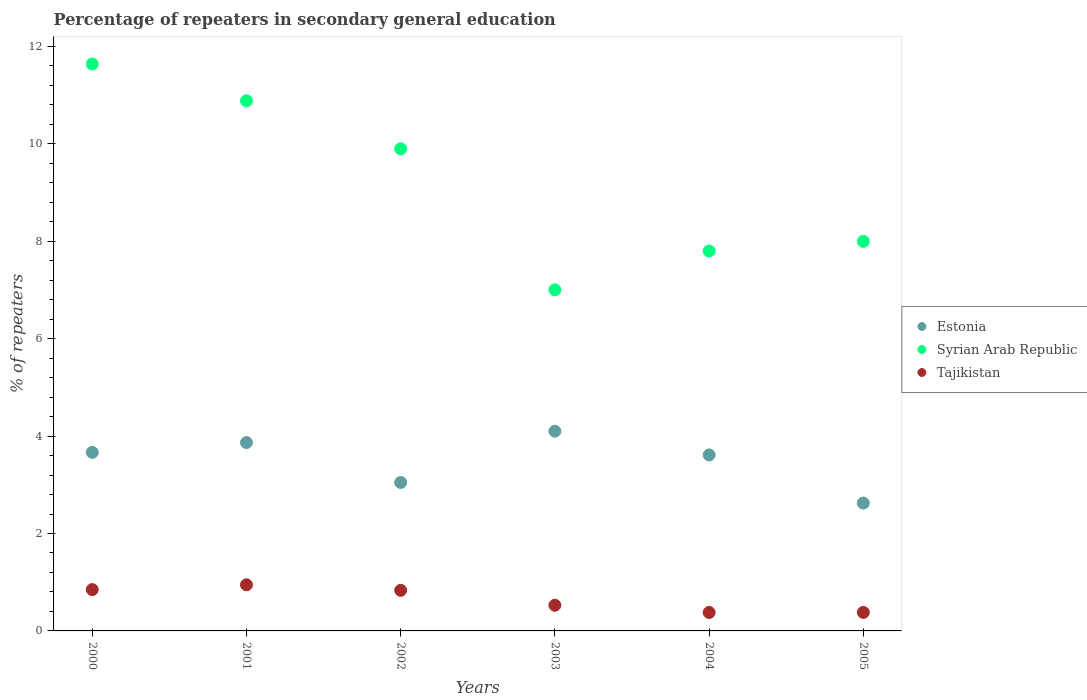What is the percentage of repeaters in secondary general education in Tajikistan in 2000?
Provide a short and direct response. 0.85. Across all years, what is the maximum percentage of repeaters in secondary general education in Syrian Arab Republic?
Provide a short and direct response. 11.64. Across all years, what is the minimum percentage of repeaters in secondary general education in Tajikistan?
Your answer should be very brief. 0.38. In which year was the percentage of repeaters in secondary general education in Tajikistan maximum?
Provide a short and direct response. 2001. In which year was the percentage of repeaters in secondary general education in Syrian Arab Republic minimum?
Offer a very short reply. 2003. What is the total percentage of repeaters in secondary general education in Syrian Arab Republic in the graph?
Make the answer very short. 55.21. What is the difference between the percentage of repeaters in secondary general education in Tajikistan in 2004 and that in 2005?
Offer a very short reply. -0. What is the difference between the percentage of repeaters in secondary general education in Estonia in 2002 and the percentage of repeaters in secondary general education in Tajikistan in 2000?
Provide a succinct answer. 2.2. What is the average percentage of repeaters in secondary general education in Estonia per year?
Your answer should be very brief. 3.49. In the year 2004, what is the difference between the percentage of repeaters in secondary general education in Syrian Arab Republic and percentage of repeaters in secondary general education in Estonia?
Offer a very short reply. 4.19. In how many years, is the percentage of repeaters in secondary general education in Syrian Arab Republic greater than 6 %?
Ensure brevity in your answer.  6. What is the ratio of the percentage of repeaters in secondary general education in Syrian Arab Republic in 2002 to that in 2003?
Offer a very short reply. 1.41. Is the percentage of repeaters in secondary general education in Syrian Arab Republic in 2000 less than that in 2002?
Offer a very short reply. No. Is the difference between the percentage of repeaters in secondary general education in Syrian Arab Republic in 2003 and 2004 greater than the difference between the percentage of repeaters in secondary general education in Estonia in 2003 and 2004?
Offer a terse response. No. What is the difference between the highest and the second highest percentage of repeaters in secondary general education in Tajikistan?
Your answer should be very brief. 0.1. What is the difference between the highest and the lowest percentage of repeaters in secondary general education in Tajikistan?
Your answer should be compact. 0.57. In how many years, is the percentage of repeaters in secondary general education in Syrian Arab Republic greater than the average percentage of repeaters in secondary general education in Syrian Arab Republic taken over all years?
Provide a short and direct response. 3. Does the percentage of repeaters in secondary general education in Tajikistan monotonically increase over the years?
Offer a very short reply. No. Is the percentage of repeaters in secondary general education in Syrian Arab Republic strictly greater than the percentage of repeaters in secondary general education in Tajikistan over the years?
Give a very brief answer. Yes. Is the percentage of repeaters in secondary general education in Syrian Arab Republic strictly less than the percentage of repeaters in secondary general education in Estonia over the years?
Your answer should be compact. No. How many years are there in the graph?
Your answer should be very brief. 6. What is the difference between two consecutive major ticks on the Y-axis?
Your answer should be compact. 2. Are the values on the major ticks of Y-axis written in scientific E-notation?
Your answer should be very brief. No. Does the graph contain grids?
Make the answer very short. No. Where does the legend appear in the graph?
Keep it short and to the point. Center right. How are the legend labels stacked?
Offer a very short reply. Vertical. What is the title of the graph?
Provide a short and direct response. Percentage of repeaters in secondary general education. Does "Tanzania" appear as one of the legend labels in the graph?
Make the answer very short. No. What is the label or title of the Y-axis?
Provide a short and direct response. % of repeaters. What is the % of repeaters of Estonia in 2000?
Provide a short and direct response. 3.67. What is the % of repeaters in Syrian Arab Republic in 2000?
Offer a very short reply. 11.64. What is the % of repeaters in Tajikistan in 2000?
Your response must be concise. 0.85. What is the % of repeaters in Estonia in 2001?
Offer a terse response. 3.87. What is the % of repeaters of Syrian Arab Republic in 2001?
Your response must be concise. 10.88. What is the % of repeaters in Tajikistan in 2001?
Your answer should be compact. 0.95. What is the % of repeaters of Estonia in 2002?
Your answer should be compact. 3.05. What is the % of repeaters in Syrian Arab Republic in 2002?
Give a very brief answer. 9.9. What is the % of repeaters in Tajikistan in 2002?
Your answer should be very brief. 0.83. What is the % of repeaters in Estonia in 2003?
Provide a succinct answer. 4.1. What is the % of repeaters of Syrian Arab Republic in 2003?
Keep it short and to the point. 7. What is the % of repeaters in Tajikistan in 2003?
Make the answer very short. 0.53. What is the % of repeaters in Estonia in 2004?
Provide a succinct answer. 3.61. What is the % of repeaters of Syrian Arab Republic in 2004?
Provide a short and direct response. 7.8. What is the % of repeaters of Tajikistan in 2004?
Ensure brevity in your answer.  0.38. What is the % of repeaters of Estonia in 2005?
Your answer should be very brief. 2.62. What is the % of repeaters of Syrian Arab Republic in 2005?
Your answer should be very brief. 8. What is the % of repeaters in Tajikistan in 2005?
Offer a terse response. 0.38. Across all years, what is the maximum % of repeaters of Estonia?
Ensure brevity in your answer.  4.1. Across all years, what is the maximum % of repeaters of Syrian Arab Republic?
Provide a succinct answer. 11.64. Across all years, what is the maximum % of repeaters in Tajikistan?
Provide a succinct answer. 0.95. Across all years, what is the minimum % of repeaters of Estonia?
Ensure brevity in your answer.  2.62. Across all years, what is the minimum % of repeaters in Syrian Arab Republic?
Your response must be concise. 7. Across all years, what is the minimum % of repeaters in Tajikistan?
Your answer should be compact. 0.38. What is the total % of repeaters of Estonia in the graph?
Your answer should be compact. 20.92. What is the total % of repeaters of Syrian Arab Republic in the graph?
Keep it short and to the point. 55.21. What is the total % of repeaters in Tajikistan in the graph?
Keep it short and to the point. 3.91. What is the difference between the % of repeaters of Estonia in 2000 and that in 2001?
Your response must be concise. -0.2. What is the difference between the % of repeaters in Syrian Arab Republic in 2000 and that in 2001?
Give a very brief answer. 0.76. What is the difference between the % of repeaters in Tajikistan in 2000 and that in 2001?
Make the answer very short. -0.1. What is the difference between the % of repeaters in Estonia in 2000 and that in 2002?
Ensure brevity in your answer.  0.62. What is the difference between the % of repeaters in Syrian Arab Republic in 2000 and that in 2002?
Your answer should be very brief. 1.74. What is the difference between the % of repeaters in Tajikistan in 2000 and that in 2002?
Your answer should be very brief. 0.01. What is the difference between the % of repeaters in Estonia in 2000 and that in 2003?
Ensure brevity in your answer.  -0.43. What is the difference between the % of repeaters of Syrian Arab Republic in 2000 and that in 2003?
Your answer should be very brief. 4.64. What is the difference between the % of repeaters of Tajikistan in 2000 and that in 2003?
Give a very brief answer. 0.32. What is the difference between the % of repeaters of Estonia in 2000 and that in 2004?
Give a very brief answer. 0.05. What is the difference between the % of repeaters of Syrian Arab Republic in 2000 and that in 2004?
Provide a succinct answer. 3.84. What is the difference between the % of repeaters of Tajikistan in 2000 and that in 2004?
Your response must be concise. 0.47. What is the difference between the % of repeaters of Estonia in 2000 and that in 2005?
Make the answer very short. 1.04. What is the difference between the % of repeaters of Syrian Arab Republic in 2000 and that in 2005?
Give a very brief answer. 3.64. What is the difference between the % of repeaters of Tajikistan in 2000 and that in 2005?
Make the answer very short. 0.47. What is the difference between the % of repeaters in Estonia in 2001 and that in 2002?
Your answer should be very brief. 0.82. What is the difference between the % of repeaters of Syrian Arab Republic in 2001 and that in 2002?
Keep it short and to the point. 0.99. What is the difference between the % of repeaters of Tajikistan in 2001 and that in 2002?
Offer a terse response. 0.11. What is the difference between the % of repeaters of Estonia in 2001 and that in 2003?
Provide a succinct answer. -0.23. What is the difference between the % of repeaters in Syrian Arab Republic in 2001 and that in 2003?
Provide a succinct answer. 3.88. What is the difference between the % of repeaters of Tajikistan in 2001 and that in 2003?
Ensure brevity in your answer.  0.42. What is the difference between the % of repeaters of Estonia in 2001 and that in 2004?
Your response must be concise. 0.25. What is the difference between the % of repeaters in Syrian Arab Republic in 2001 and that in 2004?
Keep it short and to the point. 3.08. What is the difference between the % of repeaters of Tajikistan in 2001 and that in 2004?
Ensure brevity in your answer.  0.57. What is the difference between the % of repeaters in Estonia in 2001 and that in 2005?
Provide a short and direct response. 1.24. What is the difference between the % of repeaters in Syrian Arab Republic in 2001 and that in 2005?
Your answer should be compact. 2.89. What is the difference between the % of repeaters in Tajikistan in 2001 and that in 2005?
Provide a succinct answer. 0.57. What is the difference between the % of repeaters in Estonia in 2002 and that in 2003?
Provide a succinct answer. -1.05. What is the difference between the % of repeaters of Syrian Arab Republic in 2002 and that in 2003?
Provide a succinct answer. 2.9. What is the difference between the % of repeaters of Tajikistan in 2002 and that in 2003?
Make the answer very short. 0.31. What is the difference between the % of repeaters of Estonia in 2002 and that in 2004?
Provide a succinct answer. -0.57. What is the difference between the % of repeaters in Syrian Arab Republic in 2002 and that in 2004?
Your answer should be compact. 2.1. What is the difference between the % of repeaters in Tajikistan in 2002 and that in 2004?
Your answer should be very brief. 0.45. What is the difference between the % of repeaters in Estonia in 2002 and that in 2005?
Offer a very short reply. 0.42. What is the difference between the % of repeaters in Syrian Arab Republic in 2002 and that in 2005?
Provide a short and direct response. 1.9. What is the difference between the % of repeaters of Tajikistan in 2002 and that in 2005?
Offer a very short reply. 0.45. What is the difference between the % of repeaters of Estonia in 2003 and that in 2004?
Keep it short and to the point. 0.49. What is the difference between the % of repeaters in Syrian Arab Republic in 2003 and that in 2004?
Your response must be concise. -0.8. What is the difference between the % of repeaters in Tajikistan in 2003 and that in 2004?
Ensure brevity in your answer.  0.15. What is the difference between the % of repeaters of Estonia in 2003 and that in 2005?
Your answer should be compact. 1.48. What is the difference between the % of repeaters in Syrian Arab Republic in 2003 and that in 2005?
Make the answer very short. -1. What is the difference between the % of repeaters in Tajikistan in 2003 and that in 2005?
Give a very brief answer. 0.15. What is the difference between the % of repeaters in Estonia in 2004 and that in 2005?
Your answer should be compact. 0.99. What is the difference between the % of repeaters in Syrian Arab Republic in 2004 and that in 2005?
Your response must be concise. -0.2. What is the difference between the % of repeaters in Tajikistan in 2004 and that in 2005?
Offer a very short reply. -0. What is the difference between the % of repeaters in Estonia in 2000 and the % of repeaters in Syrian Arab Republic in 2001?
Your answer should be compact. -7.22. What is the difference between the % of repeaters of Estonia in 2000 and the % of repeaters of Tajikistan in 2001?
Give a very brief answer. 2.72. What is the difference between the % of repeaters in Syrian Arab Republic in 2000 and the % of repeaters in Tajikistan in 2001?
Ensure brevity in your answer.  10.69. What is the difference between the % of repeaters in Estonia in 2000 and the % of repeaters in Syrian Arab Republic in 2002?
Your answer should be compact. -6.23. What is the difference between the % of repeaters of Estonia in 2000 and the % of repeaters of Tajikistan in 2002?
Keep it short and to the point. 2.83. What is the difference between the % of repeaters of Syrian Arab Republic in 2000 and the % of repeaters of Tajikistan in 2002?
Provide a short and direct response. 10.8. What is the difference between the % of repeaters in Estonia in 2000 and the % of repeaters in Syrian Arab Republic in 2003?
Ensure brevity in your answer.  -3.34. What is the difference between the % of repeaters in Estonia in 2000 and the % of repeaters in Tajikistan in 2003?
Provide a succinct answer. 3.14. What is the difference between the % of repeaters of Syrian Arab Republic in 2000 and the % of repeaters of Tajikistan in 2003?
Your answer should be very brief. 11.11. What is the difference between the % of repeaters in Estonia in 2000 and the % of repeaters in Syrian Arab Republic in 2004?
Your answer should be compact. -4.13. What is the difference between the % of repeaters in Estonia in 2000 and the % of repeaters in Tajikistan in 2004?
Give a very brief answer. 3.29. What is the difference between the % of repeaters of Syrian Arab Republic in 2000 and the % of repeaters of Tajikistan in 2004?
Your answer should be very brief. 11.26. What is the difference between the % of repeaters in Estonia in 2000 and the % of repeaters in Syrian Arab Republic in 2005?
Keep it short and to the point. -4.33. What is the difference between the % of repeaters of Estonia in 2000 and the % of repeaters of Tajikistan in 2005?
Your response must be concise. 3.28. What is the difference between the % of repeaters of Syrian Arab Republic in 2000 and the % of repeaters of Tajikistan in 2005?
Give a very brief answer. 11.26. What is the difference between the % of repeaters of Estonia in 2001 and the % of repeaters of Syrian Arab Republic in 2002?
Your answer should be very brief. -6.03. What is the difference between the % of repeaters of Estonia in 2001 and the % of repeaters of Tajikistan in 2002?
Your answer should be compact. 3.03. What is the difference between the % of repeaters in Syrian Arab Republic in 2001 and the % of repeaters in Tajikistan in 2002?
Your answer should be compact. 10.05. What is the difference between the % of repeaters of Estonia in 2001 and the % of repeaters of Syrian Arab Republic in 2003?
Provide a succinct answer. -3.14. What is the difference between the % of repeaters in Estonia in 2001 and the % of repeaters in Tajikistan in 2003?
Make the answer very short. 3.34. What is the difference between the % of repeaters in Syrian Arab Republic in 2001 and the % of repeaters in Tajikistan in 2003?
Your answer should be very brief. 10.36. What is the difference between the % of repeaters of Estonia in 2001 and the % of repeaters of Syrian Arab Republic in 2004?
Give a very brief answer. -3.93. What is the difference between the % of repeaters of Estonia in 2001 and the % of repeaters of Tajikistan in 2004?
Provide a short and direct response. 3.49. What is the difference between the % of repeaters in Syrian Arab Republic in 2001 and the % of repeaters in Tajikistan in 2004?
Provide a succinct answer. 10.5. What is the difference between the % of repeaters of Estonia in 2001 and the % of repeaters of Syrian Arab Republic in 2005?
Keep it short and to the point. -4.13. What is the difference between the % of repeaters of Estonia in 2001 and the % of repeaters of Tajikistan in 2005?
Ensure brevity in your answer.  3.49. What is the difference between the % of repeaters in Syrian Arab Republic in 2001 and the % of repeaters in Tajikistan in 2005?
Your answer should be compact. 10.5. What is the difference between the % of repeaters in Estonia in 2002 and the % of repeaters in Syrian Arab Republic in 2003?
Offer a terse response. -3.95. What is the difference between the % of repeaters in Estonia in 2002 and the % of repeaters in Tajikistan in 2003?
Make the answer very short. 2.52. What is the difference between the % of repeaters of Syrian Arab Republic in 2002 and the % of repeaters of Tajikistan in 2003?
Make the answer very short. 9.37. What is the difference between the % of repeaters of Estonia in 2002 and the % of repeaters of Syrian Arab Republic in 2004?
Your answer should be compact. -4.75. What is the difference between the % of repeaters in Estonia in 2002 and the % of repeaters in Tajikistan in 2004?
Give a very brief answer. 2.67. What is the difference between the % of repeaters of Syrian Arab Republic in 2002 and the % of repeaters of Tajikistan in 2004?
Provide a succinct answer. 9.52. What is the difference between the % of repeaters of Estonia in 2002 and the % of repeaters of Syrian Arab Republic in 2005?
Provide a succinct answer. -4.95. What is the difference between the % of repeaters in Estonia in 2002 and the % of repeaters in Tajikistan in 2005?
Offer a terse response. 2.67. What is the difference between the % of repeaters of Syrian Arab Republic in 2002 and the % of repeaters of Tajikistan in 2005?
Offer a very short reply. 9.52. What is the difference between the % of repeaters in Estonia in 2003 and the % of repeaters in Syrian Arab Republic in 2004?
Keep it short and to the point. -3.7. What is the difference between the % of repeaters in Estonia in 2003 and the % of repeaters in Tajikistan in 2004?
Your answer should be very brief. 3.72. What is the difference between the % of repeaters of Syrian Arab Republic in 2003 and the % of repeaters of Tajikistan in 2004?
Give a very brief answer. 6.62. What is the difference between the % of repeaters in Estonia in 2003 and the % of repeaters in Syrian Arab Republic in 2005?
Give a very brief answer. -3.9. What is the difference between the % of repeaters in Estonia in 2003 and the % of repeaters in Tajikistan in 2005?
Your answer should be compact. 3.72. What is the difference between the % of repeaters in Syrian Arab Republic in 2003 and the % of repeaters in Tajikistan in 2005?
Provide a short and direct response. 6.62. What is the difference between the % of repeaters of Estonia in 2004 and the % of repeaters of Syrian Arab Republic in 2005?
Offer a very short reply. -4.38. What is the difference between the % of repeaters of Estonia in 2004 and the % of repeaters of Tajikistan in 2005?
Your answer should be very brief. 3.23. What is the difference between the % of repeaters of Syrian Arab Republic in 2004 and the % of repeaters of Tajikistan in 2005?
Your answer should be very brief. 7.42. What is the average % of repeaters in Estonia per year?
Provide a succinct answer. 3.49. What is the average % of repeaters in Syrian Arab Republic per year?
Offer a terse response. 9.2. What is the average % of repeaters in Tajikistan per year?
Keep it short and to the point. 0.65. In the year 2000, what is the difference between the % of repeaters of Estonia and % of repeaters of Syrian Arab Republic?
Your answer should be compact. -7.97. In the year 2000, what is the difference between the % of repeaters in Estonia and % of repeaters in Tajikistan?
Offer a very short reply. 2.82. In the year 2000, what is the difference between the % of repeaters of Syrian Arab Republic and % of repeaters of Tajikistan?
Offer a very short reply. 10.79. In the year 2001, what is the difference between the % of repeaters of Estonia and % of repeaters of Syrian Arab Republic?
Your response must be concise. -7.02. In the year 2001, what is the difference between the % of repeaters in Estonia and % of repeaters in Tajikistan?
Your answer should be compact. 2.92. In the year 2001, what is the difference between the % of repeaters in Syrian Arab Republic and % of repeaters in Tajikistan?
Your answer should be compact. 9.94. In the year 2002, what is the difference between the % of repeaters of Estonia and % of repeaters of Syrian Arab Republic?
Your answer should be compact. -6.85. In the year 2002, what is the difference between the % of repeaters in Estonia and % of repeaters in Tajikistan?
Provide a succinct answer. 2.21. In the year 2002, what is the difference between the % of repeaters in Syrian Arab Republic and % of repeaters in Tajikistan?
Offer a terse response. 9.06. In the year 2003, what is the difference between the % of repeaters in Estonia and % of repeaters in Syrian Arab Republic?
Ensure brevity in your answer.  -2.9. In the year 2003, what is the difference between the % of repeaters of Estonia and % of repeaters of Tajikistan?
Give a very brief answer. 3.57. In the year 2003, what is the difference between the % of repeaters of Syrian Arab Republic and % of repeaters of Tajikistan?
Give a very brief answer. 6.47. In the year 2004, what is the difference between the % of repeaters in Estonia and % of repeaters in Syrian Arab Republic?
Your response must be concise. -4.19. In the year 2004, what is the difference between the % of repeaters in Estonia and % of repeaters in Tajikistan?
Your answer should be very brief. 3.23. In the year 2004, what is the difference between the % of repeaters of Syrian Arab Republic and % of repeaters of Tajikistan?
Ensure brevity in your answer.  7.42. In the year 2005, what is the difference between the % of repeaters in Estonia and % of repeaters in Syrian Arab Republic?
Offer a terse response. -5.37. In the year 2005, what is the difference between the % of repeaters in Estonia and % of repeaters in Tajikistan?
Your answer should be very brief. 2.24. In the year 2005, what is the difference between the % of repeaters in Syrian Arab Republic and % of repeaters in Tajikistan?
Give a very brief answer. 7.62. What is the ratio of the % of repeaters in Estonia in 2000 to that in 2001?
Make the answer very short. 0.95. What is the ratio of the % of repeaters of Syrian Arab Republic in 2000 to that in 2001?
Your answer should be very brief. 1.07. What is the ratio of the % of repeaters of Tajikistan in 2000 to that in 2001?
Your response must be concise. 0.9. What is the ratio of the % of repeaters of Estonia in 2000 to that in 2002?
Offer a very short reply. 1.2. What is the ratio of the % of repeaters of Syrian Arab Republic in 2000 to that in 2002?
Keep it short and to the point. 1.18. What is the ratio of the % of repeaters in Tajikistan in 2000 to that in 2002?
Offer a terse response. 1.02. What is the ratio of the % of repeaters of Estonia in 2000 to that in 2003?
Offer a very short reply. 0.89. What is the ratio of the % of repeaters in Syrian Arab Republic in 2000 to that in 2003?
Keep it short and to the point. 1.66. What is the ratio of the % of repeaters of Tajikistan in 2000 to that in 2003?
Your response must be concise. 1.61. What is the ratio of the % of repeaters in Estonia in 2000 to that in 2004?
Give a very brief answer. 1.01. What is the ratio of the % of repeaters in Syrian Arab Republic in 2000 to that in 2004?
Offer a terse response. 1.49. What is the ratio of the % of repeaters of Tajikistan in 2000 to that in 2004?
Make the answer very short. 2.24. What is the ratio of the % of repeaters of Estonia in 2000 to that in 2005?
Your answer should be compact. 1.4. What is the ratio of the % of repeaters in Syrian Arab Republic in 2000 to that in 2005?
Provide a succinct answer. 1.46. What is the ratio of the % of repeaters in Tajikistan in 2000 to that in 2005?
Keep it short and to the point. 2.23. What is the ratio of the % of repeaters of Estonia in 2001 to that in 2002?
Your response must be concise. 1.27. What is the ratio of the % of repeaters of Syrian Arab Republic in 2001 to that in 2002?
Keep it short and to the point. 1.1. What is the ratio of the % of repeaters of Tajikistan in 2001 to that in 2002?
Offer a terse response. 1.14. What is the ratio of the % of repeaters in Estonia in 2001 to that in 2003?
Your answer should be compact. 0.94. What is the ratio of the % of repeaters in Syrian Arab Republic in 2001 to that in 2003?
Provide a succinct answer. 1.55. What is the ratio of the % of repeaters in Tajikistan in 2001 to that in 2003?
Provide a short and direct response. 1.8. What is the ratio of the % of repeaters in Estonia in 2001 to that in 2004?
Ensure brevity in your answer.  1.07. What is the ratio of the % of repeaters of Syrian Arab Republic in 2001 to that in 2004?
Provide a short and direct response. 1.4. What is the ratio of the % of repeaters in Tajikistan in 2001 to that in 2004?
Make the answer very short. 2.5. What is the ratio of the % of repeaters of Estonia in 2001 to that in 2005?
Your answer should be very brief. 1.47. What is the ratio of the % of repeaters of Syrian Arab Republic in 2001 to that in 2005?
Provide a short and direct response. 1.36. What is the ratio of the % of repeaters of Tajikistan in 2001 to that in 2005?
Give a very brief answer. 2.49. What is the ratio of the % of repeaters in Estonia in 2002 to that in 2003?
Make the answer very short. 0.74. What is the ratio of the % of repeaters of Syrian Arab Republic in 2002 to that in 2003?
Provide a succinct answer. 1.41. What is the ratio of the % of repeaters in Tajikistan in 2002 to that in 2003?
Offer a terse response. 1.58. What is the ratio of the % of repeaters in Estonia in 2002 to that in 2004?
Ensure brevity in your answer.  0.84. What is the ratio of the % of repeaters of Syrian Arab Republic in 2002 to that in 2004?
Provide a succinct answer. 1.27. What is the ratio of the % of repeaters in Tajikistan in 2002 to that in 2004?
Ensure brevity in your answer.  2.2. What is the ratio of the % of repeaters in Estonia in 2002 to that in 2005?
Keep it short and to the point. 1.16. What is the ratio of the % of repeaters of Syrian Arab Republic in 2002 to that in 2005?
Provide a succinct answer. 1.24. What is the ratio of the % of repeaters in Tajikistan in 2002 to that in 2005?
Offer a very short reply. 2.19. What is the ratio of the % of repeaters of Estonia in 2003 to that in 2004?
Ensure brevity in your answer.  1.14. What is the ratio of the % of repeaters in Syrian Arab Republic in 2003 to that in 2004?
Your answer should be very brief. 0.9. What is the ratio of the % of repeaters of Tajikistan in 2003 to that in 2004?
Give a very brief answer. 1.39. What is the ratio of the % of repeaters of Estonia in 2003 to that in 2005?
Ensure brevity in your answer.  1.56. What is the ratio of the % of repeaters in Syrian Arab Republic in 2003 to that in 2005?
Ensure brevity in your answer.  0.88. What is the ratio of the % of repeaters in Tajikistan in 2003 to that in 2005?
Ensure brevity in your answer.  1.39. What is the ratio of the % of repeaters in Estonia in 2004 to that in 2005?
Keep it short and to the point. 1.38. What is the ratio of the % of repeaters in Syrian Arab Republic in 2004 to that in 2005?
Make the answer very short. 0.98. What is the difference between the highest and the second highest % of repeaters in Estonia?
Offer a terse response. 0.23. What is the difference between the highest and the second highest % of repeaters of Syrian Arab Republic?
Make the answer very short. 0.76. What is the difference between the highest and the second highest % of repeaters of Tajikistan?
Give a very brief answer. 0.1. What is the difference between the highest and the lowest % of repeaters in Estonia?
Provide a succinct answer. 1.48. What is the difference between the highest and the lowest % of repeaters of Syrian Arab Republic?
Give a very brief answer. 4.64. What is the difference between the highest and the lowest % of repeaters in Tajikistan?
Your answer should be compact. 0.57. 